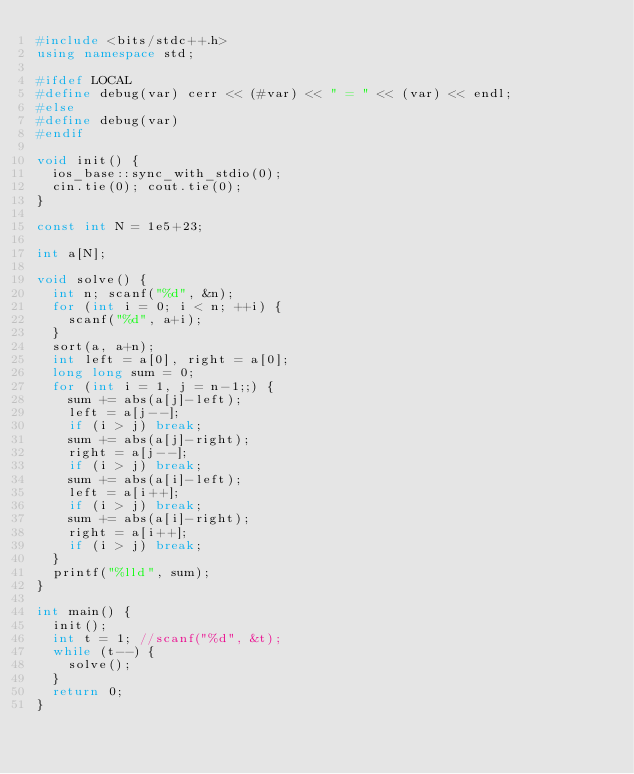Convert code to text. <code><loc_0><loc_0><loc_500><loc_500><_C++_>#include <bits/stdc++.h>
using namespace std;

#ifdef LOCAL
#define debug(var) cerr << (#var) << " = " << (var) << endl;
#else
#define debug(var)
#endif

void init() {
  ios_base::sync_with_stdio(0);
  cin.tie(0); cout.tie(0);
}

const int N = 1e5+23;

int a[N];

void solve() {
  int n; scanf("%d", &n);
  for (int i = 0; i < n; ++i) {
    scanf("%d", a+i);
  }
  sort(a, a+n);
  int left = a[0], right = a[0];
  long long sum = 0;
  for (int i = 1, j = n-1;;) {
    sum += abs(a[j]-left);
    left = a[j--];
    if (i > j) break;
    sum += abs(a[j]-right);
    right = a[j--];
    if (i > j) break;
    sum += abs(a[i]-left);
    left = a[i++];
    if (i > j) break;
    sum += abs(a[i]-right);
    right = a[i++];
    if (i > j) break;
  }
  printf("%lld", sum);
}

int main() {
  init();
  int t = 1; //scanf("%d", &t);
  while (t--) {
    solve();
  }
  return 0;
}
</code> 